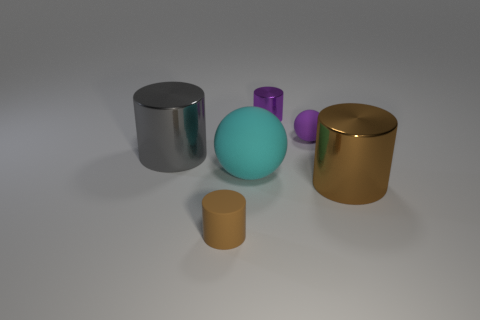Subtract all matte cylinders. How many cylinders are left? 3 Add 3 tiny brown objects. How many objects exist? 9 Subtract all brown cylinders. How many cylinders are left? 2 Subtract all blue blocks. How many brown cylinders are left? 2 Subtract all cylinders. How many objects are left? 2 Subtract all brown metal balls. Subtract all tiny rubber cylinders. How many objects are left? 5 Add 3 cylinders. How many cylinders are left? 7 Add 4 tiny yellow metallic cylinders. How many tiny yellow metallic cylinders exist? 4 Subtract 0 green balls. How many objects are left? 6 Subtract 2 cylinders. How many cylinders are left? 2 